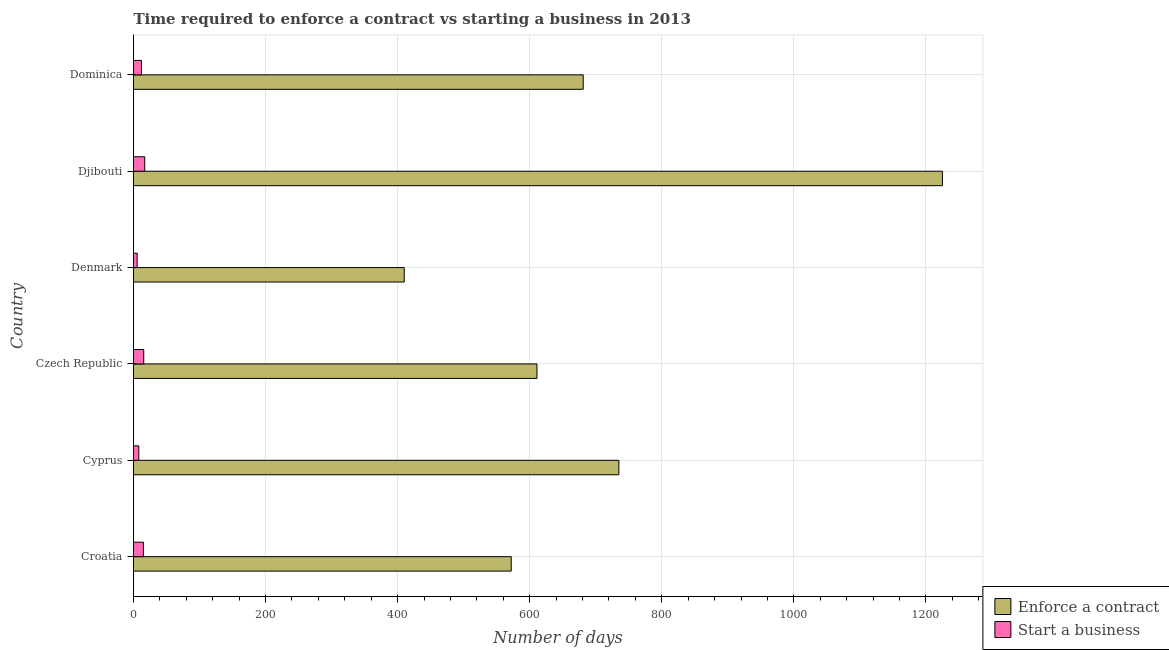How many groups of bars are there?
Your response must be concise. 6. Are the number of bars per tick equal to the number of legend labels?
Your answer should be compact. Yes. Are the number of bars on each tick of the Y-axis equal?
Your answer should be compact. Yes. How many bars are there on the 3rd tick from the top?
Your answer should be compact. 2. What is the label of the 5th group of bars from the top?
Your response must be concise. Cyprus. What is the number of days to enforece a contract in Dominica?
Make the answer very short. 681. Across all countries, what is the maximum number of days to enforece a contract?
Ensure brevity in your answer.  1225. Across all countries, what is the minimum number of days to enforece a contract?
Keep it short and to the point. 410. In which country was the number of days to start a business maximum?
Offer a terse response. Djibouti. What is the total number of days to enforece a contract in the graph?
Provide a short and direct response. 4234. What is the difference between the number of days to enforece a contract in Cyprus and the number of days to start a business in Dominica?
Your answer should be very brief. 723. What is the average number of days to start a business per country?
Offer a terse response. 12.17. What is the difference between the number of days to enforece a contract and number of days to start a business in Czech Republic?
Make the answer very short. 595.5. What is the ratio of the number of days to start a business in Cyprus to that in Czech Republic?
Make the answer very short. 0.52. Is the number of days to enforece a contract in Czech Republic less than that in Djibouti?
Keep it short and to the point. Yes. Is the difference between the number of days to start a business in Denmark and Dominica greater than the difference between the number of days to enforece a contract in Denmark and Dominica?
Your answer should be compact. Yes. What is the difference between the highest and the second highest number of days to enforece a contract?
Your answer should be very brief. 490. What is the difference between the highest and the lowest number of days to start a business?
Keep it short and to the point. 11.5. In how many countries, is the number of days to enforece a contract greater than the average number of days to enforece a contract taken over all countries?
Ensure brevity in your answer.  2. What does the 2nd bar from the top in Dominica represents?
Your response must be concise. Enforce a contract. What does the 2nd bar from the bottom in Czech Republic represents?
Make the answer very short. Start a business. Are all the bars in the graph horizontal?
Offer a very short reply. Yes. How many countries are there in the graph?
Offer a terse response. 6. What is the difference between two consecutive major ticks on the X-axis?
Give a very brief answer. 200. Where does the legend appear in the graph?
Provide a succinct answer. Bottom right. How are the legend labels stacked?
Your answer should be very brief. Vertical. What is the title of the graph?
Make the answer very short. Time required to enforce a contract vs starting a business in 2013. What is the label or title of the X-axis?
Your answer should be very brief. Number of days. What is the Number of days of Enforce a contract in Croatia?
Give a very brief answer. 572. What is the Number of days in Enforce a contract in Cyprus?
Offer a terse response. 735. What is the Number of days in Enforce a contract in Czech Republic?
Provide a short and direct response. 611. What is the Number of days in Start a business in Czech Republic?
Make the answer very short. 15.5. What is the Number of days in Enforce a contract in Denmark?
Your response must be concise. 410. What is the Number of days of Enforce a contract in Djibouti?
Ensure brevity in your answer.  1225. What is the Number of days in Enforce a contract in Dominica?
Provide a short and direct response. 681. What is the Number of days in Start a business in Dominica?
Offer a very short reply. 12. Across all countries, what is the maximum Number of days in Enforce a contract?
Give a very brief answer. 1225. Across all countries, what is the minimum Number of days in Enforce a contract?
Your answer should be compact. 410. Across all countries, what is the minimum Number of days of Start a business?
Make the answer very short. 5.5. What is the total Number of days of Enforce a contract in the graph?
Your answer should be compact. 4234. What is the total Number of days of Start a business in the graph?
Give a very brief answer. 73. What is the difference between the Number of days of Enforce a contract in Croatia and that in Cyprus?
Make the answer very short. -163. What is the difference between the Number of days in Enforce a contract in Croatia and that in Czech Republic?
Offer a very short reply. -39. What is the difference between the Number of days in Start a business in Croatia and that in Czech Republic?
Your answer should be very brief. -0.5. What is the difference between the Number of days of Enforce a contract in Croatia and that in Denmark?
Your answer should be very brief. 162. What is the difference between the Number of days in Enforce a contract in Croatia and that in Djibouti?
Give a very brief answer. -653. What is the difference between the Number of days of Start a business in Croatia and that in Djibouti?
Make the answer very short. -2. What is the difference between the Number of days of Enforce a contract in Croatia and that in Dominica?
Provide a succinct answer. -109. What is the difference between the Number of days in Enforce a contract in Cyprus and that in Czech Republic?
Keep it short and to the point. 124. What is the difference between the Number of days of Start a business in Cyprus and that in Czech Republic?
Give a very brief answer. -7.5. What is the difference between the Number of days in Enforce a contract in Cyprus and that in Denmark?
Your response must be concise. 325. What is the difference between the Number of days of Start a business in Cyprus and that in Denmark?
Your answer should be very brief. 2.5. What is the difference between the Number of days in Enforce a contract in Cyprus and that in Djibouti?
Provide a short and direct response. -490. What is the difference between the Number of days of Start a business in Cyprus and that in Djibouti?
Give a very brief answer. -9. What is the difference between the Number of days in Start a business in Cyprus and that in Dominica?
Your response must be concise. -4. What is the difference between the Number of days in Enforce a contract in Czech Republic and that in Denmark?
Your answer should be very brief. 201. What is the difference between the Number of days in Enforce a contract in Czech Republic and that in Djibouti?
Keep it short and to the point. -614. What is the difference between the Number of days in Enforce a contract in Czech Republic and that in Dominica?
Provide a short and direct response. -70. What is the difference between the Number of days in Start a business in Czech Republic and that in Dominica?
Your answer should be compact. 3.5. What is the difference between the Number of days in Enforce a contract in Denmark and that in Djibouti?
Provide a succinct answer. -815. What is the difference between the Number of days in Start a business in Denmark and that in Djibouti?
Keep it short and to the point. -11.5. What is the difference between the Number of days in Enforce a contract in Denmark and that in Dominica?
Provide a succinct answer. -271. What is the difference between the Number of days in Enforce a contract in Djibouti and that in Dominica?
Provide a succinct answer. 544. What is the difference between the Number of days of Enforce a contract in Croatia and the Number of days of Start a business in Cyprus?
Provide a short and direct response. 564. What is the difference between the Number of days of Enforce a contract in Croatia and the Number of days of Start a business in Czech Republic?
Give a very brief answer. 556.5. What is the difference between the Number of days of Enforce a contract in Croatia and the Number of days of Start a business in Denmark?
Give a very brief answer. 566.5. What is the difference between the Number of days of Enforce a contract in Croatia and the Number of days of Start a business in Djibouti?
Keep it short and to the point. 555. What is the difference between the Number of days in Enforce a contract in Croatia and the Number of days in Start a business in Dominica?
Give a very brief answer. 560. What is the difference between the Number of days in Enforce a contract in Cyprus and the Number of days in Start a business in Czech Republic?
Keep it short and to the point. 719.5. What is the difference between the Number of days of Enforce a contract in Cyprus and the Number of days of Start a business in Denmark?
Offer a terse response. 729.5. What is the difference between the Number of days in Enforce a contract in Cyprus and the Number of days in Start a business in Djibouti?
Your answer should be compact. 718. What is the difference between the Number of days of Enforce a contract in Cyprus and the Number of days of Start a business in Dominica?
Provide a short and direct response. 723. What is the difference between the Number of days of Enforce a contract in Czech Republic and the Number of days of Start a business in Denmark?
Offer a terse response. 605.5. What is the difference between the Number of days of Enforce a contract in Czech Republic and the Number of days of Start a business in Djibouti?
Make the answer very short. 594. What is the difference between the Number of days of Enforce a contract in Czech Republic and the Number of days of Start a business in Dominica?
Make the answer very short. 599. What is the difference between the Number of days in Enforce a contract in Denmark and the Number of days in Start a business in Djibouti?
Provide a succinct answer. 393. What is the difference between the Number of days of Enforce a contract in Denmark and the Number of days of Start a business in Dominica?
Provide a succinct answer. 398. What is the difference between the Number of days in Enforce a contract in Djibouti and the Number of days in Start a business in Dominica?
Keep it short and to the point. 1213. What is the average Number of days in Enforce a contract per country?
Your answer should be very brief. 705.67. What is the average Number of days of Start a business per country?
Offer a very short reply. 12.17. What is the difference between the Number of days of Enforce a contract and Number of days of Start a business in Croatia?
Offer a terse response. 557. What is the difference between the Number of days of Enforce a contract and Number of days of Start a business in Cyprus?
Make the answer very short. 727. What is the difference between the Number of days of Enforce a contract and Number of days of Start a business in Czech Republic?
Give a very brief answer. 595.5. What is the difference between the Number of days of Enforce a contract and Number of days of Start a business in Denmark?
Your answer should be compact. 404.5. What is the difference between the Number of days in Enforce a contract and Number of days in Start a business in Djibouti?
Make the answer very short. 1208. What is the difference between the Number of days in Enforce a contract and Number of days in Start a business in Dominica?
Keep it short and to the point. 669. What is the ratio of the Number of days of Enforce a contract in Croatia to that in Cyprus?
Your answer should be very brief. 0.78. What is the ratio of the Number of days of Start a business in Croatia to that in Cyprus?
Your response must be concise. 1.88. What is the ratio of the Number of days in Enforce a contract in Croatia to that in Czech Republic?
Your response must be concise. 0.94. What is the ratio of the Number of days of Enforce a contract in Croatia to that in Denmark?
Provide a succinct answer. 1.4. What is the ratio of the Number of days in Start a business in Croatia to that in Denmark?
Keep it short and to the point. 2.73. What is the ratio of the Number of days of Enforce a contract in Croatia to that in Djibouti?
Make the answer very short. 0.47. What is the ratio of the Number of days in Start a business in Croatia to that in Djibouti?
Offer a terse response. 0.88. What is the ratio of the Number of days in Enforce a contract in Croatia to that in Dominica?
Give a very brief answer. 0.84. What is the ratio of the Number of days of Start a business in Croatia to that in Dominica?
Provide a short and direct response. 1.25. What is the ratio of the Number of days in Enforce a contract in Cyprus to that in Czech Republic?
Offer a very short reply. 1.2. What is the ratio of the Number of days in Start a business in Cyprus to that in Czech Republic?
Offer a very short reply. 0.52. What is the ratio of the Number of days of Enforce a contract in Cyprus to that in Denmark?
Your answer should be compact. 1.79. What is the ratio of the Number of days of Start a business in Cyprus to that in Denmark?
Your answer should be very brief. 1.45. What is the ratio of the Number of days of Start a business in Cyprus to that in Djibouti?
Your answer should be compact. 0.47. What is the ratio of the Number of days in Enforce a contract in Cyprus to that in Dominica?
Offer a very short reply. 1.08. What is the ratio of the Number of days of Enforce a contract in Czech Republic to that in Denmark?
Give a very brief answer. 1.49. What is the ratio of the Number of days of Start a business in Czech Republic to that in Denmark?
Give a very brief answer. 2.82. What is the ratio of the Number of days in Enforce a contract in Czech Republic to that in Djibouti?
Your answer should be very brief. 0.5. What is the ratio of the Number of days in Start a business in Czech Republic to that in Djibouti?
Your answer should be very brief. 0.91. What is the ratio of the Number of days of Enforce a contract in Czech Republic to that in Dominica?
Make the answer very short. 0.9. What is the ratio of the Number of days in Start a business in Czech Republic to that in Dominica?
Ensure brevity in your answer.  1.29. What is the ratio of the Number of days in Enforce a contract in Denmark to that in Djibouti?
Make the answer very short. 0.33. What is the ratio of the Number of days in Start a business in Denmark to that in Djibouti?
Ensure brevity in your answer.  0.32. What is the ratio of the Number of days of Enforce a contract in Denmark to that in Dominica?
Your answer should be very brief. 0.6. What is the ratio of the Number of days of Start a business in Denmark to that in Dominica?
Provide a succinct answer. 0.46. What is the ratio of the Number of days in Enforce a contract in Djibouti to that in Dominica?
Ensure brevity in your answer.  1.8. What is the ratio of the Number of days of Start a business in Djibouti to that in Dominica?
Ensure brevity in your answer.  1.42. What is the difference between the highest and the second highest Number of days in Enforce a contract?
Provide a short and direct response. 490. What is the difference between the highest and the lowest Number of days of Enforce a contract?
Provide a succinct answer. 815. What is the difference between the highest and the lowest Number of days in Start a business?
Keep it short and to the point. 11.5. 